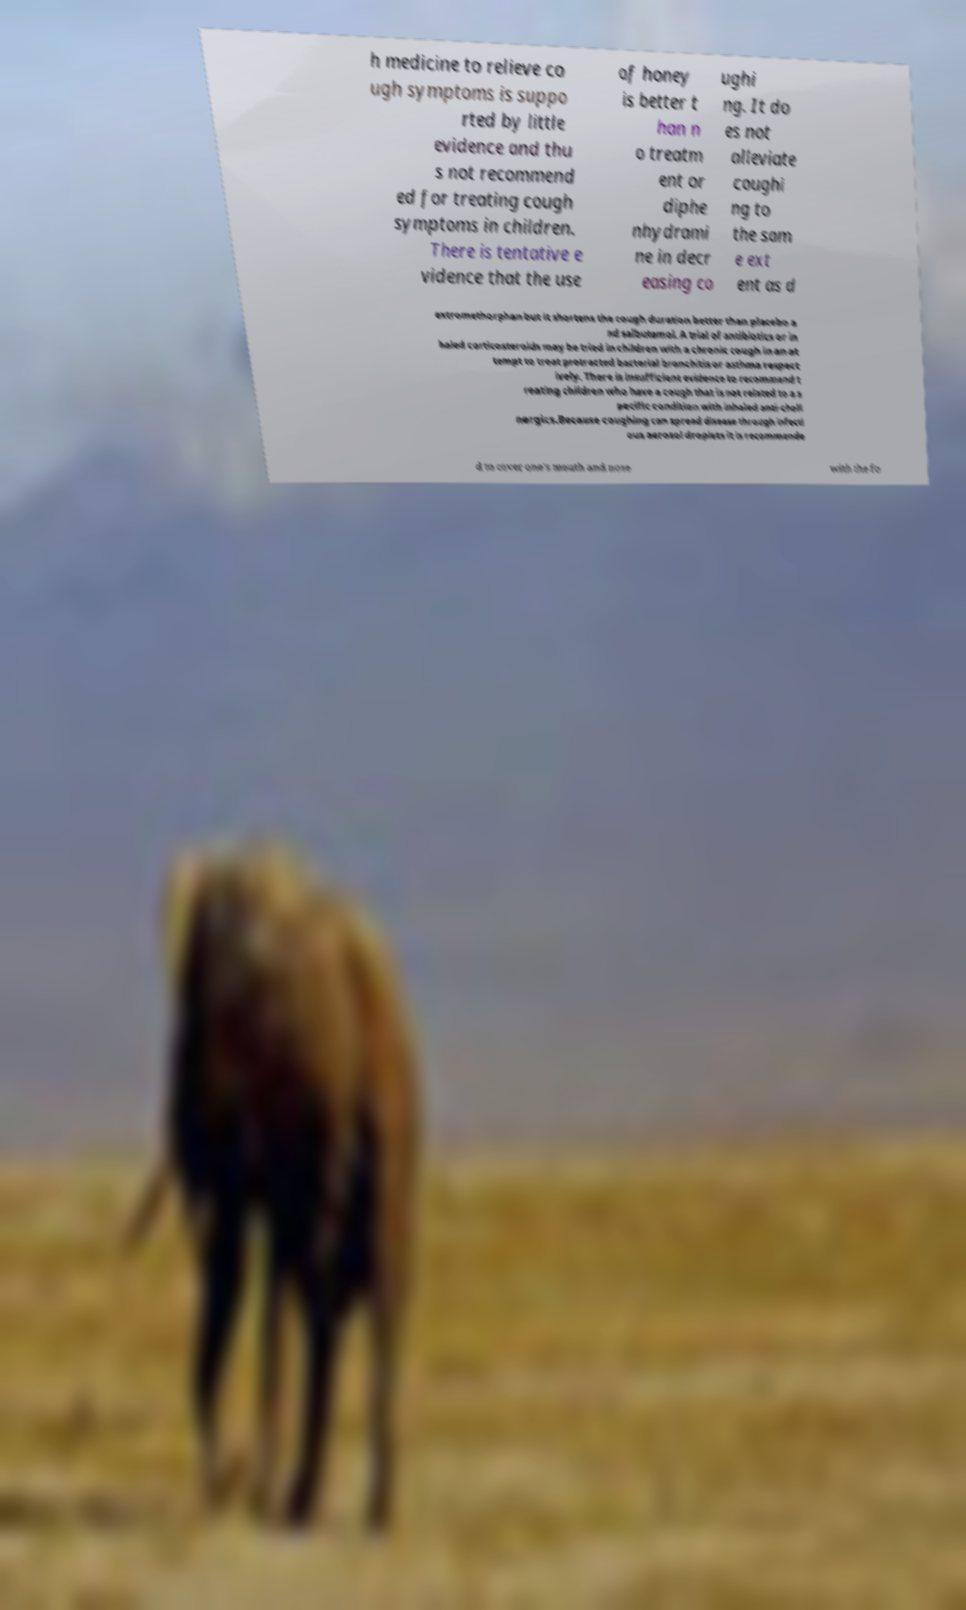I need the written content from this picture converted into text. Can you do that? h medicine to relieve co ugh symptoms is suppo rted by little evidence and thu s not recommend ed for treating cough symptoms in children. There is tentative e vidence that the use of honey is better t han n o treatm ent or diphe nhydrami ne in decr easing co ughi ng. It do es not alleviate coughi ng to the sam e ext ent as d extromethorphan but it shortens the cough duration better than placebo a nd salbutamol. A trial of antibiotics or in haled corticosteroids may be tried in children with a chronic cough in an at tempt to treat protracted bacterial bronchitis or asthma respect ively. There is insufficient evidence to recommend t reating children who have a cough that is not related to a s pecific condition with inhaled anti-choli nergics.Because coughing can spread disease through infecti ous aerosol droplets it is recommende d to cover one's mouth and nose with the fo 